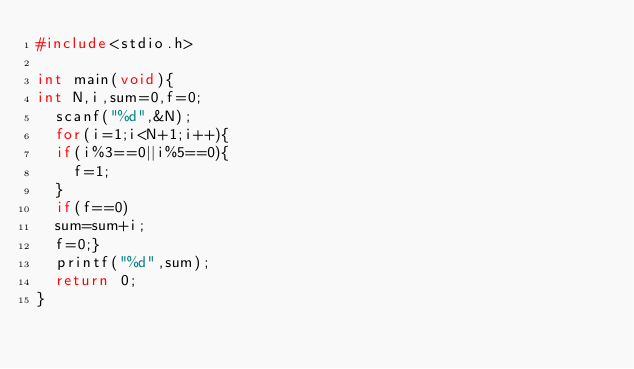<code> <loc_0><loc_0><loc_500><loc_500><_C_>#include<stdio.h>
 
int main(void){
int N,i,sum=0,f=0;
  scanf("%d",&N);
  for(i=1;i<N+1;i++){
  if(i%3==0||i%5==0){
    f=1;
  }
  if(f==0)
  sum=sum+i;
  f=0;}
  printf("%d",sum);
  return 0;
}</code> 